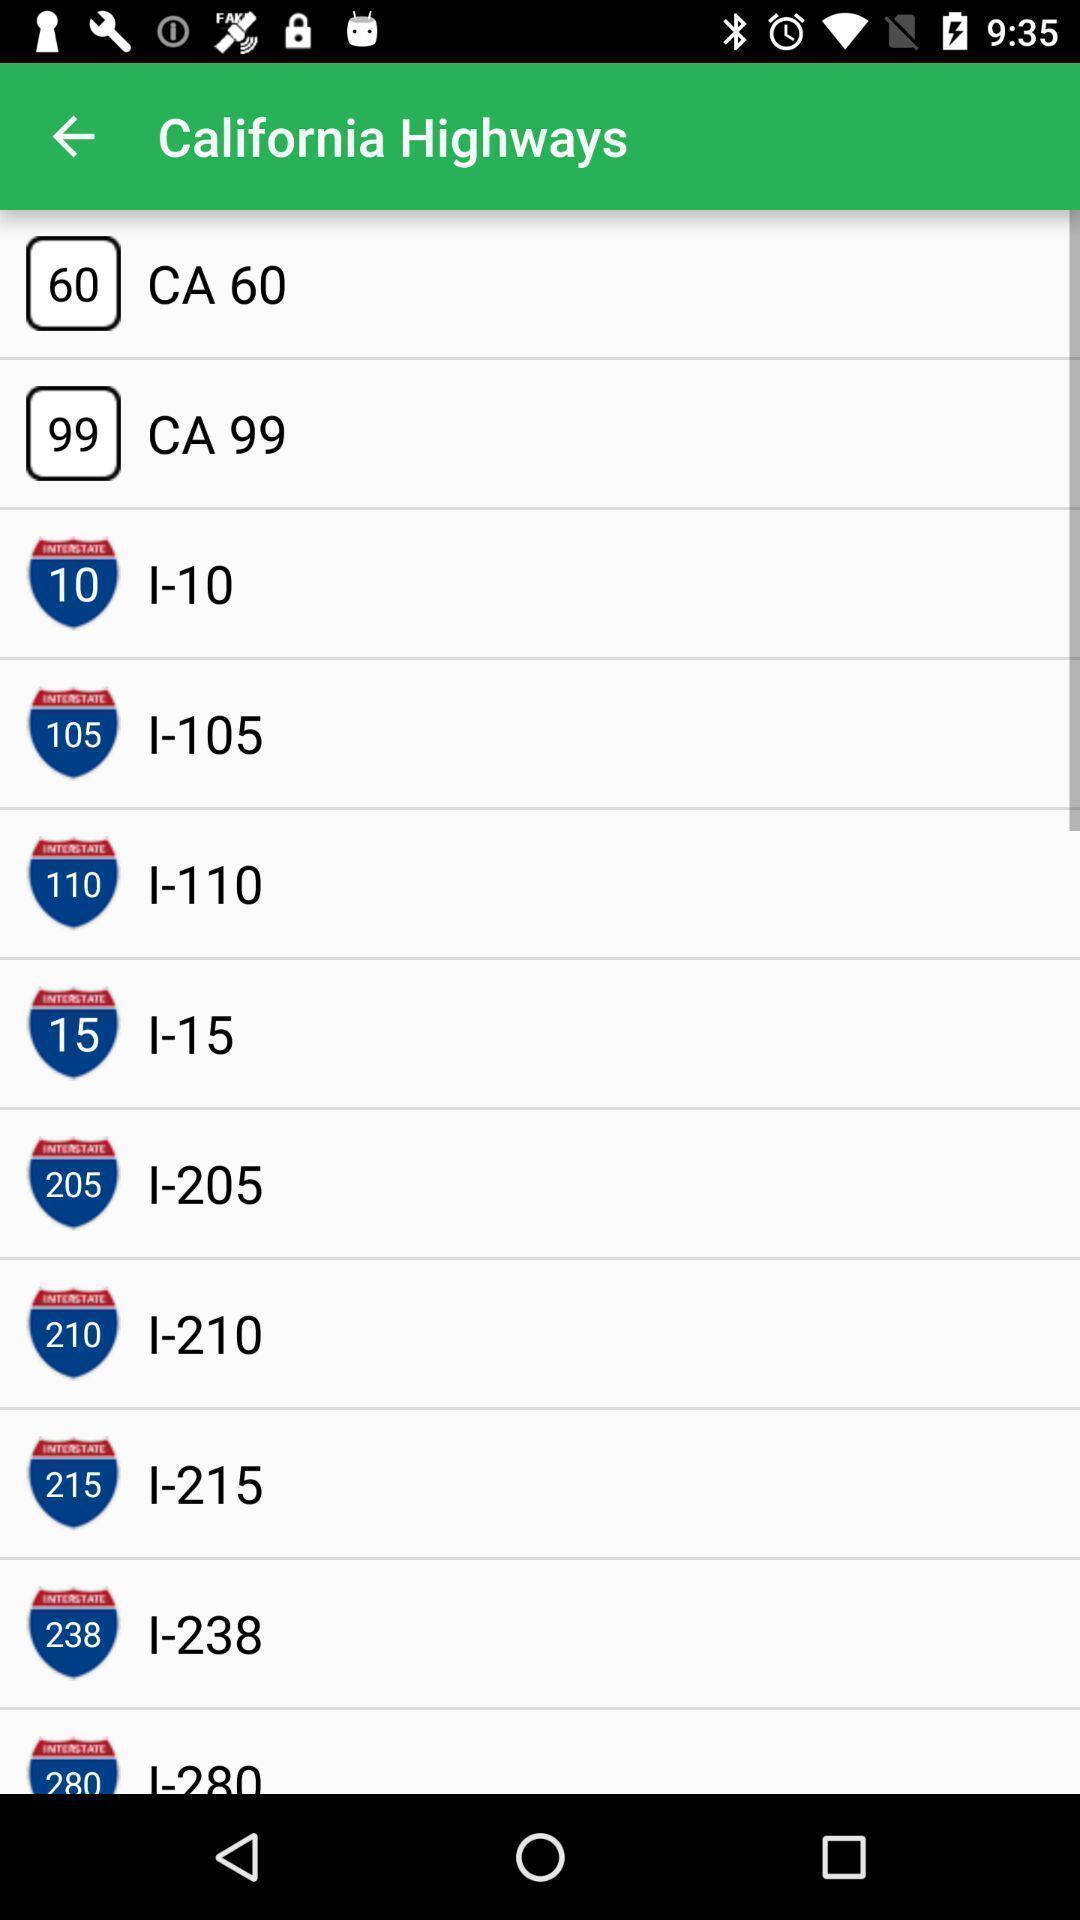Describe the key features of this screenshot. Various highways details displayed. 